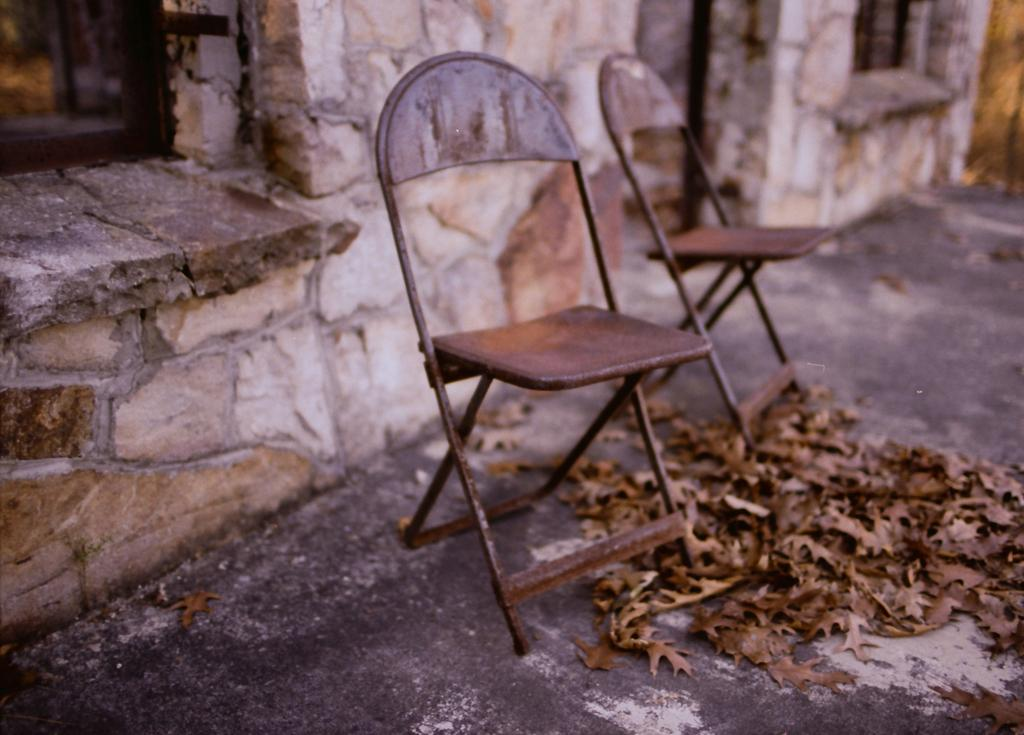What type of furniture can be seen in the image? There are chairs in the image. What is on the ground in the image? Dry leaves are present on the ground. What can be seen in the background of the image? There is a wall with windows in the background of the image. How many trucks are driving past the wall with windows in the image? There are no trucks or driving activity present in the image. What type of glass is used for the windows in the image? The type of glass used for the windows cannot be determined from the image. 